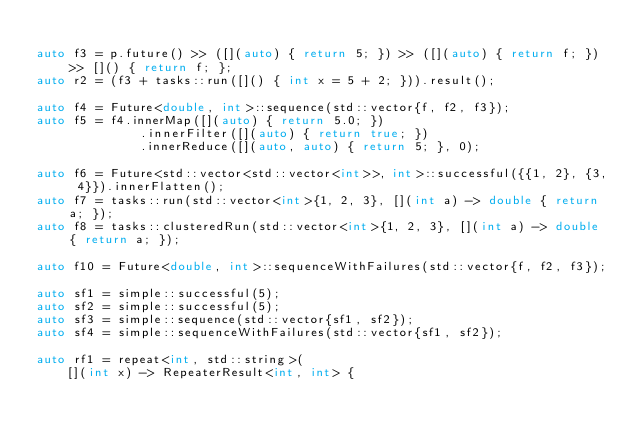<code> <loc_0><loc_0><loc_500><loc_500><_C++_>
auto f3 = p.future() >> ([](auto) { return 5; }) >> ([](auto) { return f; }) >> []() { return f; };
auto r2 = (f3 + tasks::run([]() { int x = 5 + 2; })).result();

auto f4 = Future<double, int>::sequence(std::vector{f, f2, f3});
auto f5 = f4.innerMap([](auto) { return 5.0; })
              .innerFilter([](auto) { return true; })
              .innerReduce([](auto, auto) { return 5; }, 0);

auto f6 = Future<std::vector<std::vector<int>>, int>::successful({{1, 2}, {3, 4}}).innerFlatten();
auto f7 = tasks::run(std::vector<int>{1, 2, 3}, [](int a) -> double { return a; });
auto f8 = tasks::clusteredRun(std::vector<int>{1, 2, 3}, [](int a) -> double { return a; });

auto f10 = Future<double, int>::sequenceWithFailures(std::vector{f, f2, f3});

auto sf1 = simple::successful(5);
auto sf2 = simple::successful(5);
auto sf3 = simple::sequence(std::vector{sf1, sf2});
auto sf4 = simple::sequenceWithFailures(std::vector{sf1, sf2});

auto rf1 = repeat<int, std::string>(
    [](int x) -> RepeaterResult<int, int> {</code> 